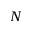Convert formula to latex. <formula><loc_0><loc_0><loc_500><loc_500>N</formula> 